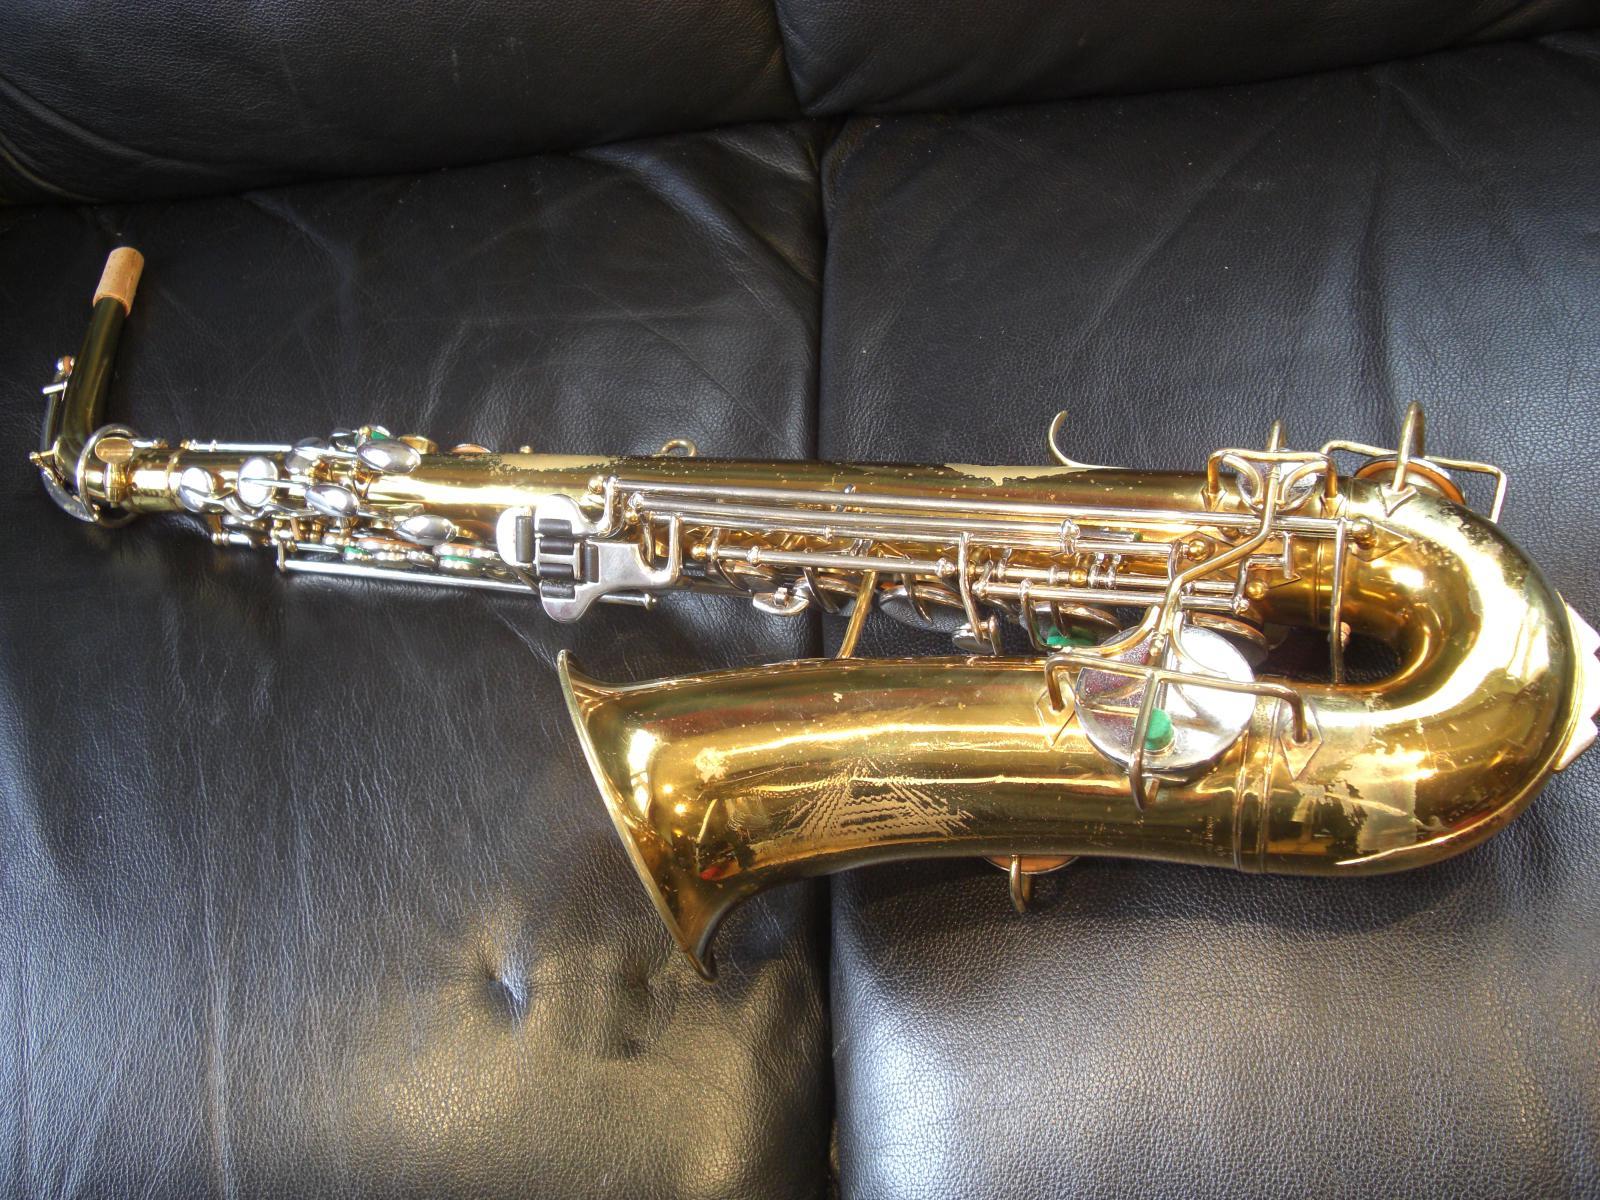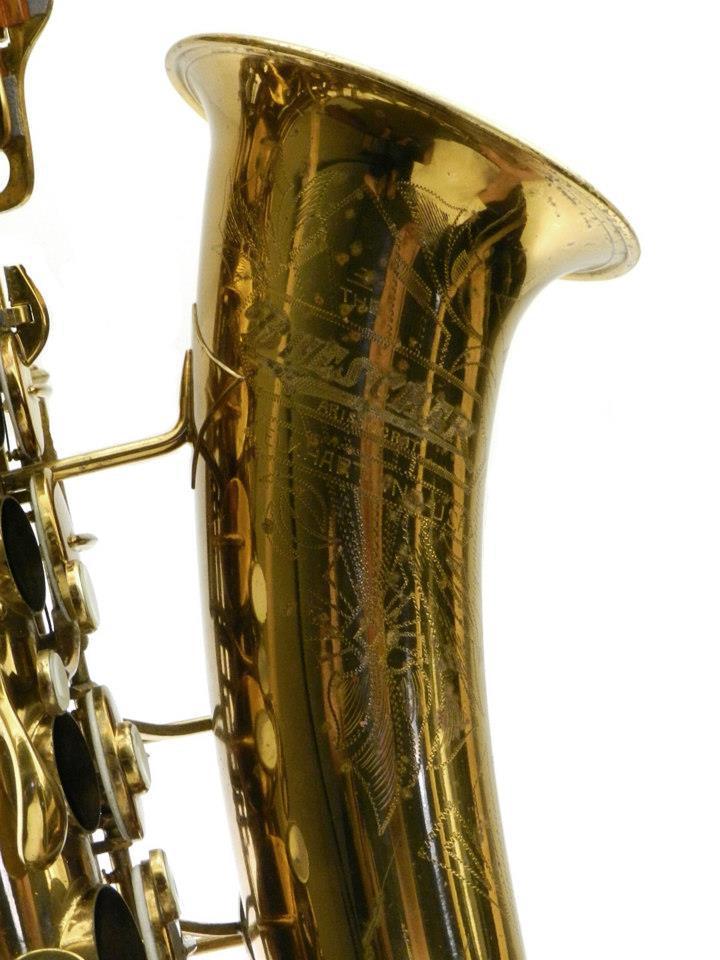The first image is the image on the left, the second image is the image on the right. Assess this claim about the two images: "One image shows the right-turned engraved bell of saxophone, and the other image shows one saxophone with mouthpiece intact.". Correct or not? Answer yes or no. Yes. The first image is the image on the left, the second image is the image on the right. For the images shown, is this caption "All the sax's are facing the same direction." true? Answer yes or no. No. 